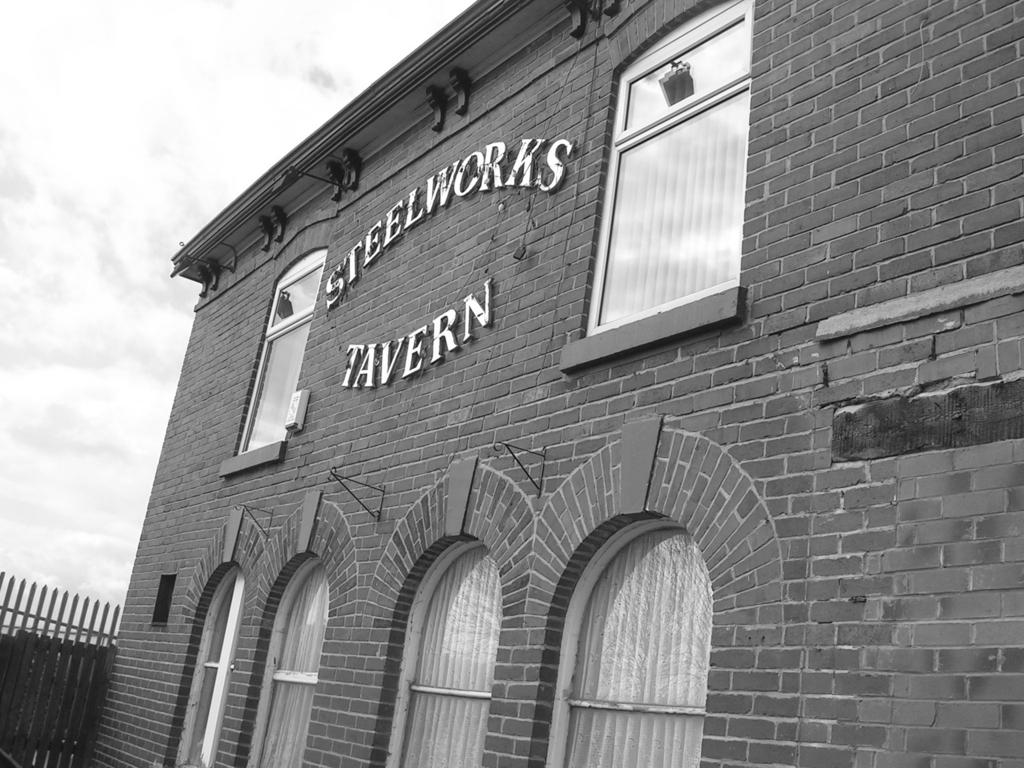What architectural feature can be seen in the image? There are arches in the image. What type of window treatment is present in the image? There are curtains in the image. What type of objects are made of glass in the image? There are glass objects in the image. What type of openings can be seen in the image? There are windows in the image. What is on the building in the image? There are things on the building in the image. What type of barrier is present in the image? There is a fence in the image. What is the condition of the sky in the image? The sky is cloudy in the image. What type of plot can be seen in the image? There is no plot present in the image; it is a photograph of a building with arches, curtains, glass objects, windows, things on the building, a fence, and a cloudy sky. What type of match can be seen in the image? There is no match present in the image; it is a photograph of a building with arches, curtains, glass objects, windows, things on the building, a fence, and a cloudy sky. 